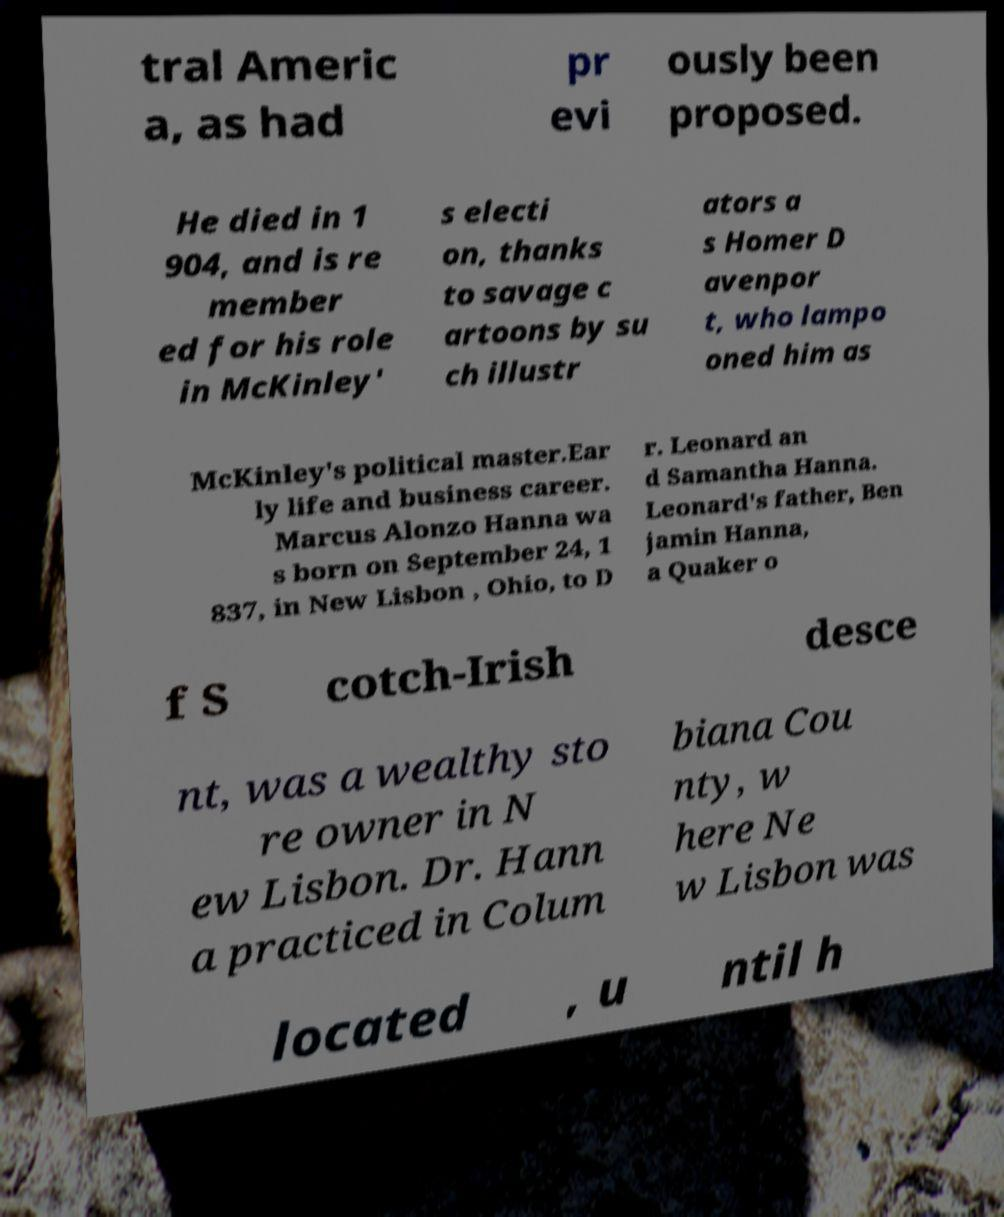There's text embedded in this image that I need extracted. Can you transcribe it verbatim? tral Americ a, as had pr evi ously been proposed. He died in 1 904, and is re member ed for his role in McKinley' s electi on, thanks to savage c artoons by su ch illustr ators a s Homer D avenpor t, who lampo oned him as McKinley's political master.Ear ly life and business career. Marcus Alonzo Hanna wa s born on September 24, 1 837, in New Lisbon , Ohio, to D r. Leonard an d Samantha Hanna. Leonard's father, Ben jamin Hanna, a Quaker o f S cotch-Irish desce nt, was a wealthy sto re owner in N ew Lisbon. Dr. Hann a practiced in Colum biana Cou nty, w here Ne w Lisbon was located , u ntil h 